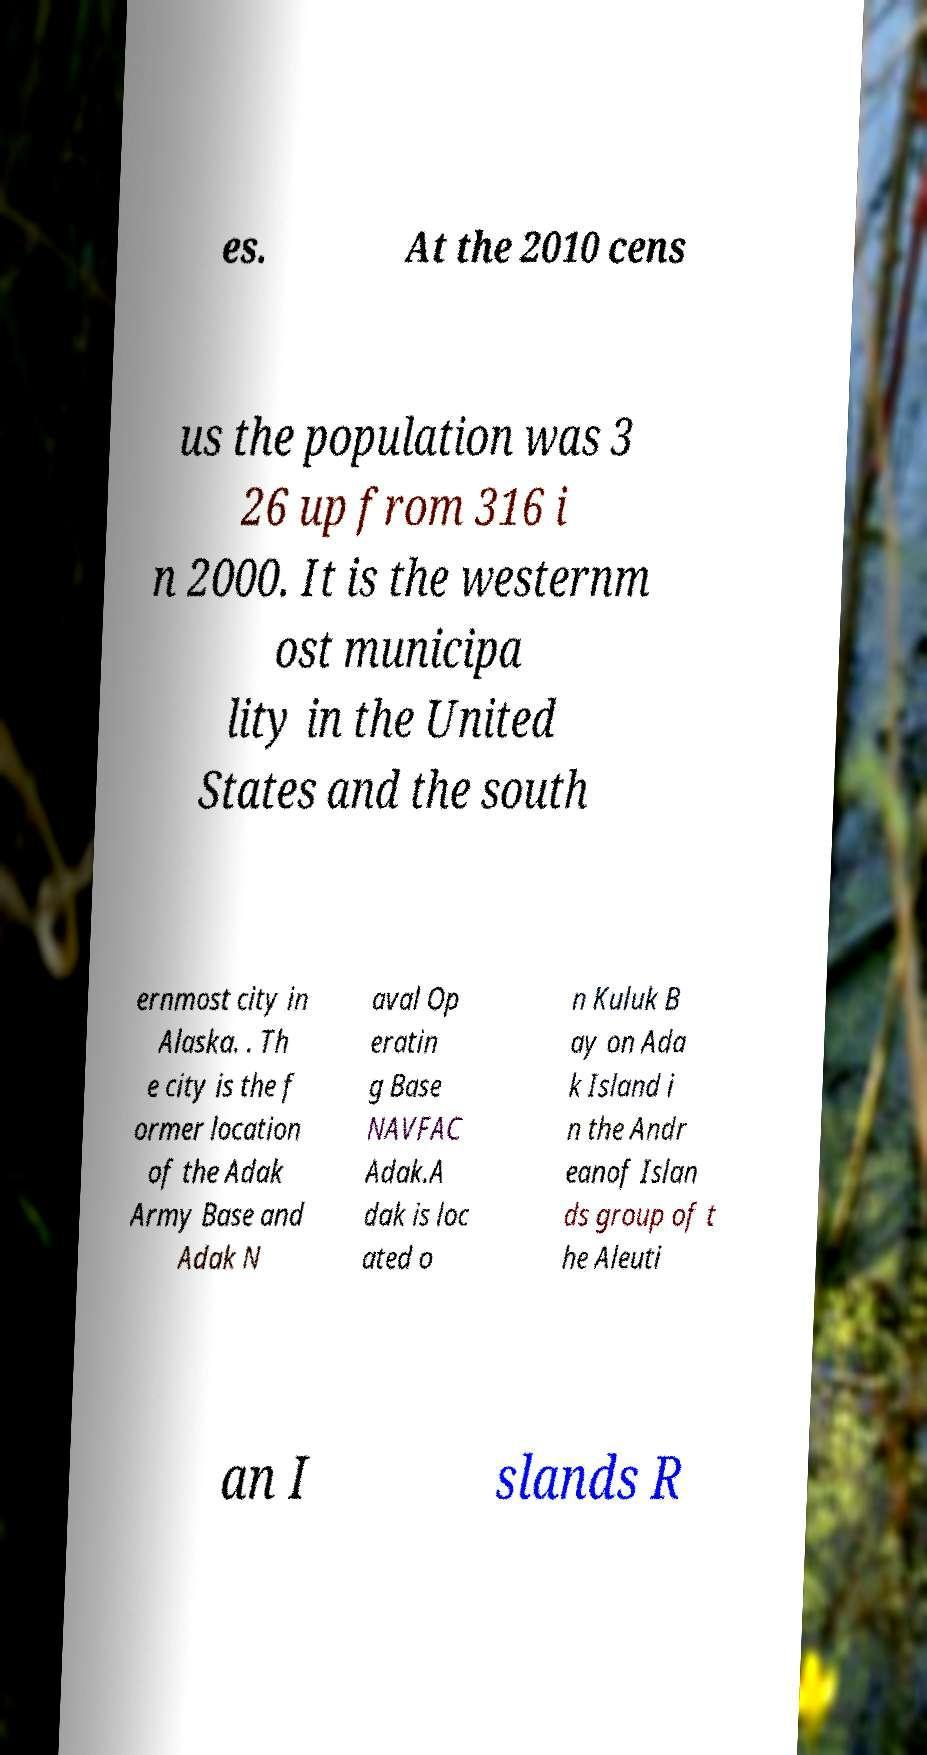Could you extract and type out the text from this image? es. At the 2010 cens us the population was 3 26 up from 316 i n 2000. It is the westernm ost municipa lity in the United States and the south ernmost city in Alaska. . Th e city is the f ormer location of the Adak Army Base and Adak N aval Op eratin g Base NAVFAC Adak.A dak is loc ated o n Kuluk B ay on Ada k Island i n the Andr eanof Islan ds group of t he Aleuti an I slands R 